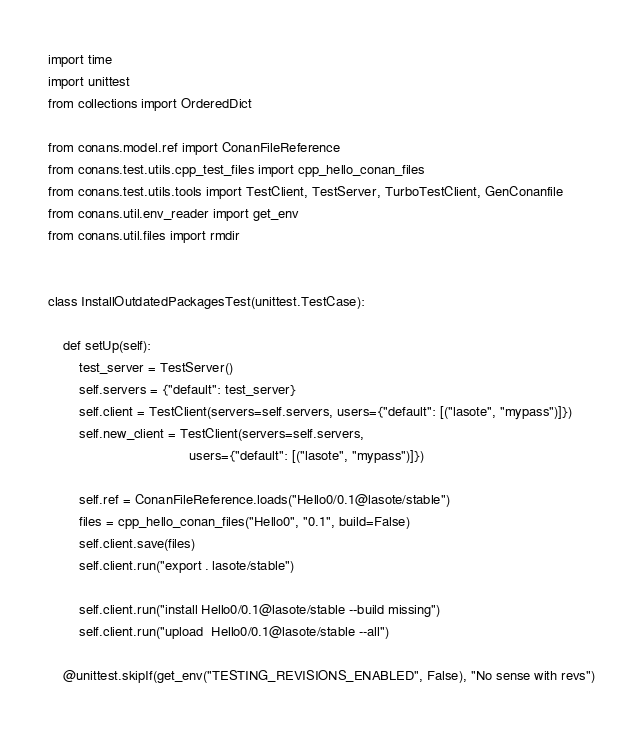<code> <loc_0><loc_0><loc_500><loc_500><_Python_>import time
import unittest
from collections import OrderedDict

from conans.model.ref import ConanFileReference
from conans.test.utils.cpp_test_files import cpp_hello_conan_files
from conans.test.utils.tools import TestClient, TestServer, TurboTestClient, GenConanfile
from conans.util.env_reader import get_env
from conans.util.files import rmdir


class InstallOutdatedPackagesTest(unittest.TestCase):

    def setUp(self):
        test_server = TestServer()
        self.servers = {"default": test_server}
        self.client = TestClient(servers=self.servers, users={"default": [("lasote", "mypass")]})
        self.new_client = TestClient(servers=self.servers,
                                     users={"default": [("lasote", "mypass")]})

        self.ref = ConanFileReference.loads("Hello0/0.1@lasote/stable")
        files = cpp_hello_conan_files("Hello0", "0.1", build=False)
        self.client.save(files)
        self.client.run("export . lasote/stable")

        self.client.run("install Hello0/0.1@lasote/stable --build missing")
        self.client.run("upload  Hello0/0.1@lasote/stable --all")

    @unittest.skipIf(get_env("TESTING_REVISIONS_ENABLED", False), "No sense with revs")</code> 